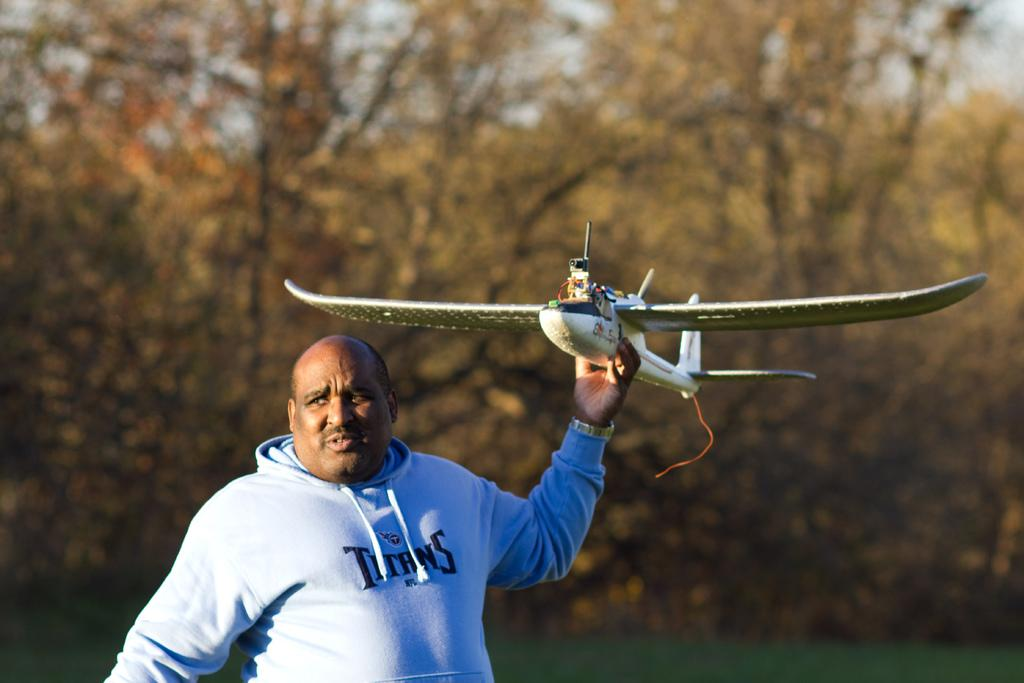<image>
Relay a brief, clear account of the picture shown. A man with a Titans sweatshirt on is throwing an RC plane. 